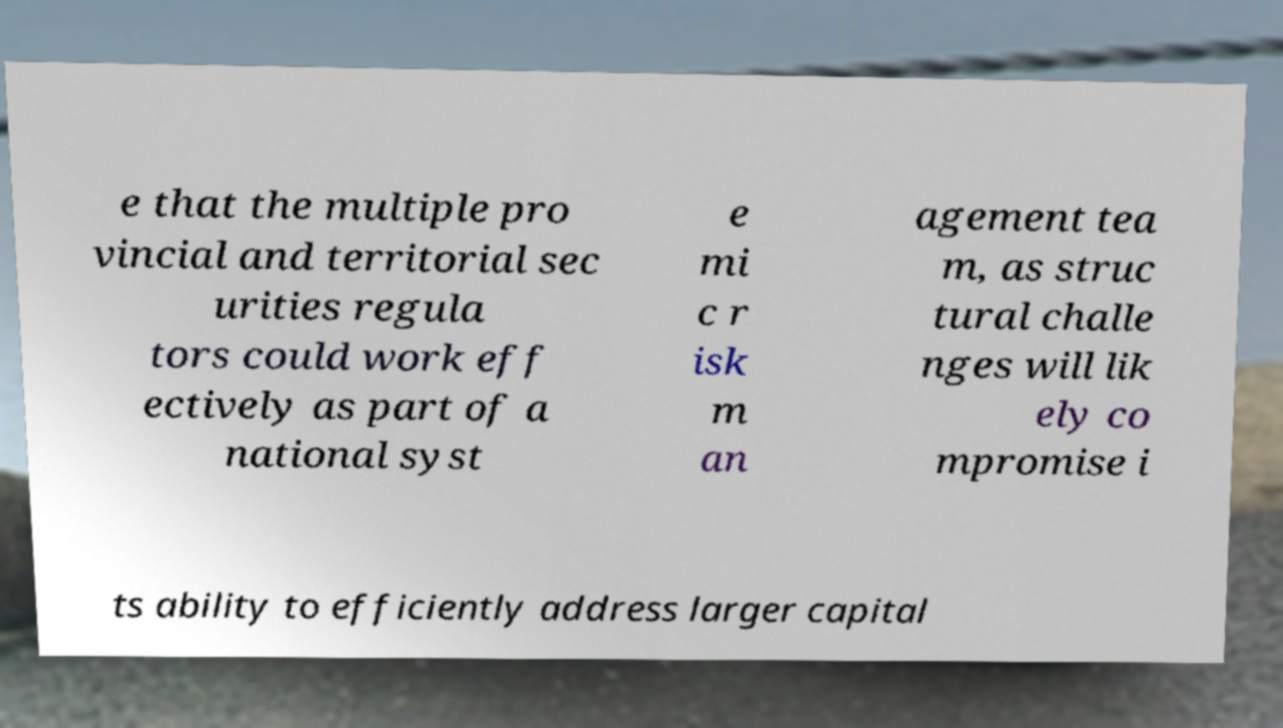Could you assist in decoding the text presented in this image and type it out clearly? e that the multiple pro vincial and territorial sec urities regula tors could work eff ectively as part of a national syst e mi c r isk m an agement tea m, as struc tural challe nges will lik ely co mpromise i ts ability to efficiently address larger capital 